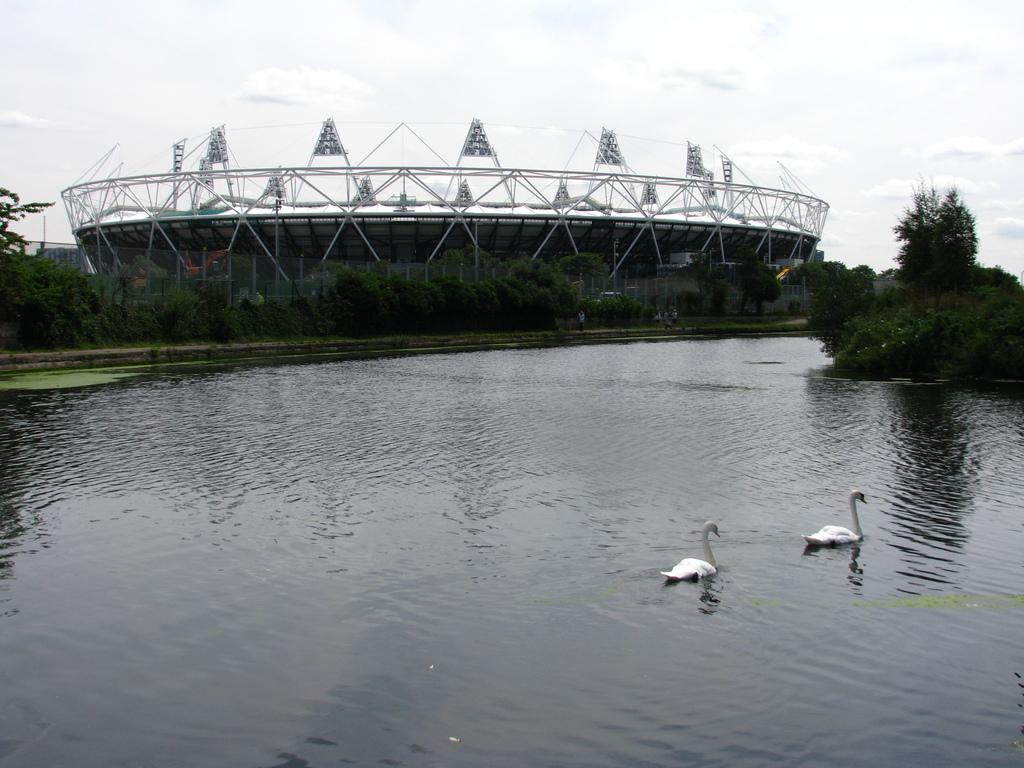What can be seen in the background of the image? The sky is visible in the background of the image. What type of structure is in the image? There is an architectural structure in the image. What type of vegetation is present in the image? Trees are present in the image. What type of barrier is in the image? There is a fence in the image. What natural element is visible in the image? Water is visible in the image. What type of animal is present in the water? Swans are present in the water. What type of wristwatch is visible on the swan's leg in the image? There is no wristwatch present on the swan's leg in the image. What is the swan's reaction to the surprise in the image? There is no surprise present in the image, and therefore no reaction from the swans can be observed. 